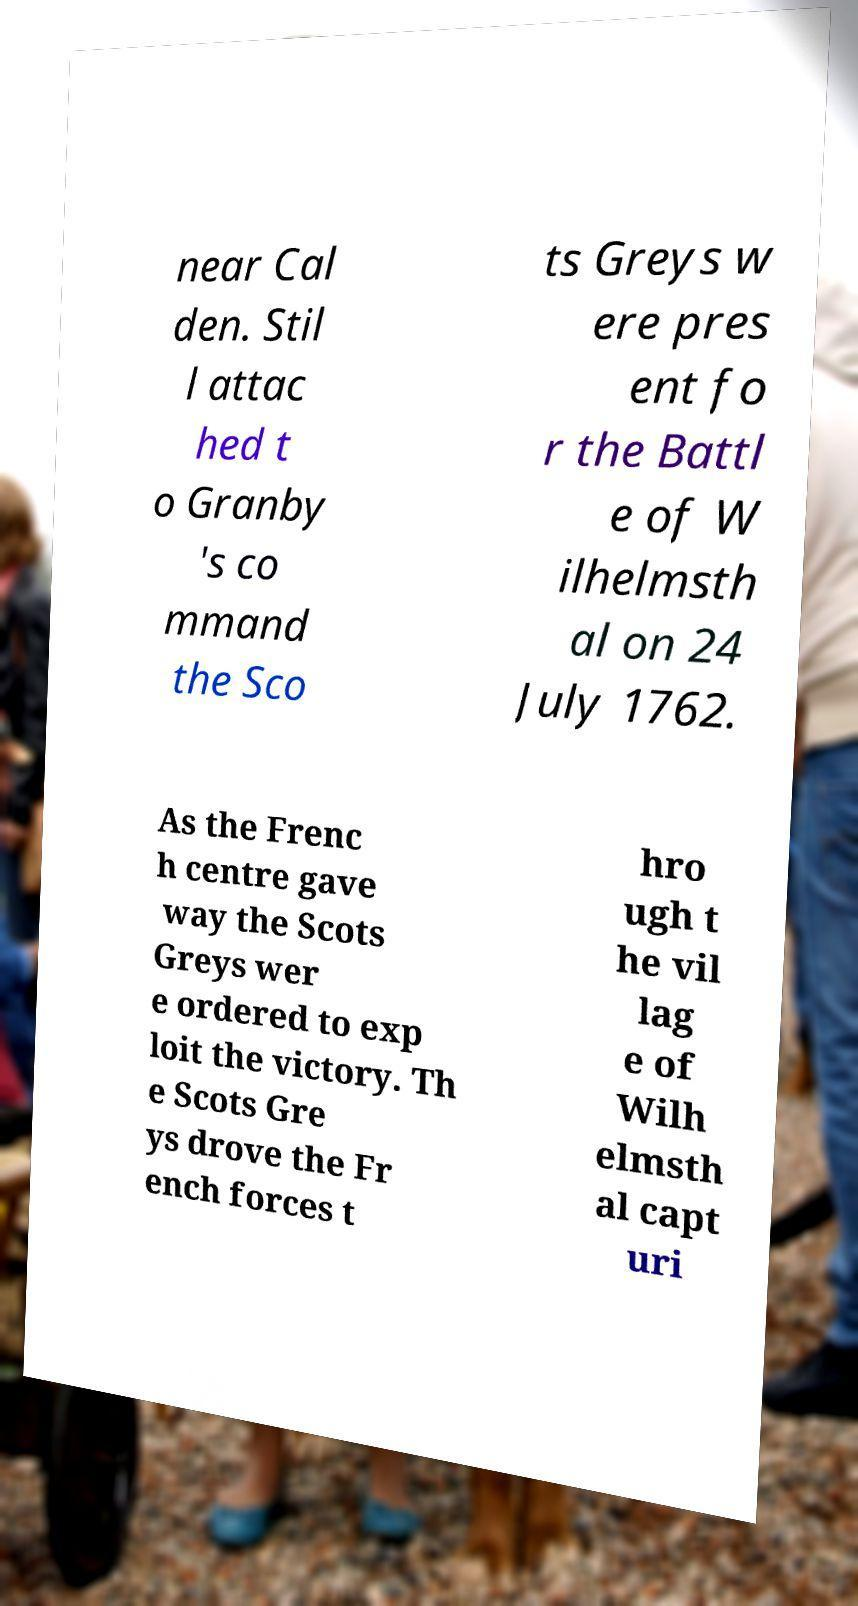There's text embedded in this image that I need extracted. Can you transcribe it verbatim? near Cal den. Stil l attac hed t o Granby 's co mmand the Sco ts Greys w ere pres ent fo r the Battl e of W ilhelmsth al on 24 July 1762. As the Frenc h centre gave way the Scots Greys wer e ordered to exp loit the victory. Th e Scots Gre ys drove the Fr ench forces t hro ugh t he vil lag e of Wilh elmsth al capt uri 